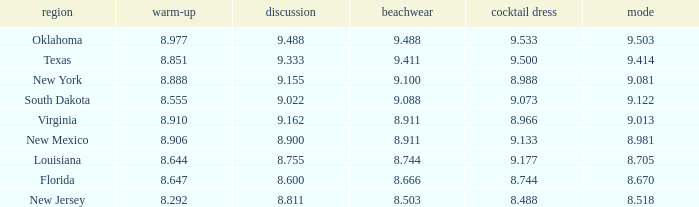 what's the evening gown where state is south dakota 9.073. 